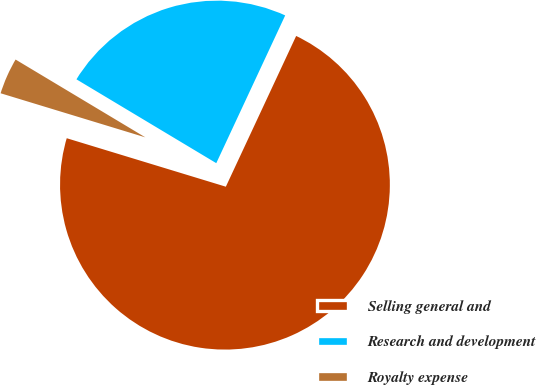Convert chart to OTSL. <chart><loc_0><loc_0><loc_500><loc_500><pie_chart><fcel>Selling general and<fcel>Research and development<fcel>Royalty expense<nl><fcel>72.76%<fcel>23.35%<fcel>3.89%<nl></chart> 